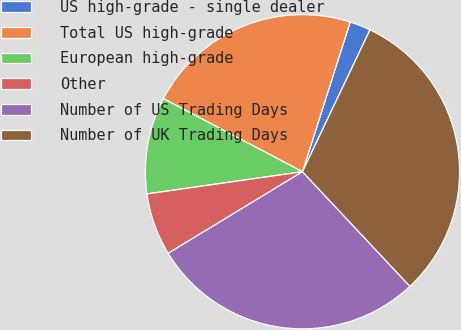Convert chart to OTSL. <chart><loc_0><loc_0><loc_500><loc_500><pie_chart><fcel>US high-grade - single dealer<fcel>Total US high-grade<fcel>European high-grade<fcel>Other<fcel>Number of US Trading Days<fcel>Number of UK Trading Days<nl><fcel>2.16%<fcel>22.21%<fcel>9.96%<fcel>6.43%<fcel>28.3%<fcel>30.94%<nl></chart> 